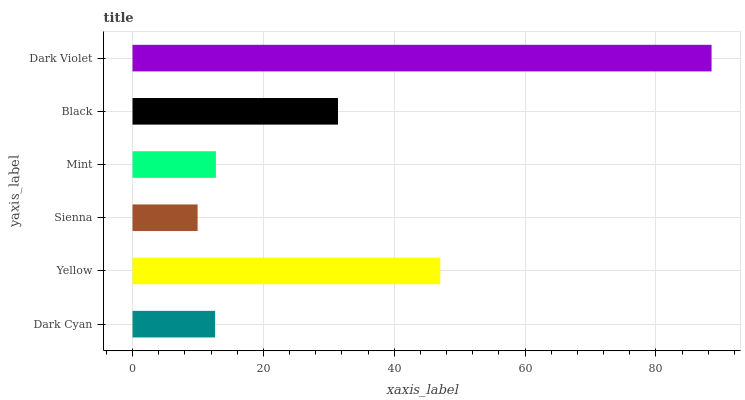Is Sienna the minimum?
Answer yes or no. Yes. Is Dark Violet the maximum?
Answer yes or no. Yes. Is Yellow the minimum?
Answer yes or no. No. Is Yellow the maximum?
Answer yes or no. No. Is Yellow greater than Dark Cyan?
Answer yes or no. Yes. Is Dark Cyan less than Yellow?
Answer yes or no. Yes. Is Dark Cyan greater than Yellow?
Answer yes or no. No. Is Yellow less than Dark Cyan?
Answer yes or no. No. Is Black the high median?
Answer yes or no. Yes. Is Mint the low median?
Answer yes or no. Yes. Is Yellow the high median?
Answer yes or no. No. Is Yellow the low median?
Answer yes or no. No. 